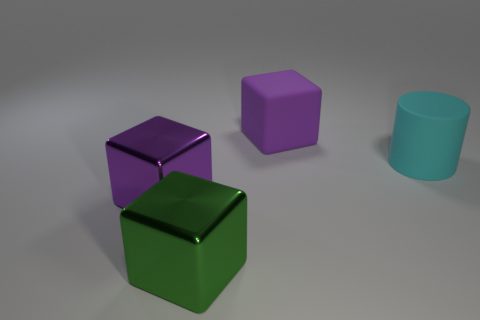Subtract all purple blocks. How many blocks are left? 1 Subtract all purple balls. How many purple blocks are left? 2 Subtract 1 blocks. How many blocks are left? 2 Subtract all green blocks. How many blocks are left? 2 Subtract all gray blocks. Subtract all brown cylinders. How many blocks are left? 3 Add 4 green cylinders. How many objects exist? 8 Subtract all cubes. How many objects are left? 1 Add 3 matte cylinders. How many matte cylinders exist? 4 Subtract 0 red blocks. How many objects are left? 4 Subtract all gray cylinders. Subtract all cyan matte things. How many objects are left? 3 